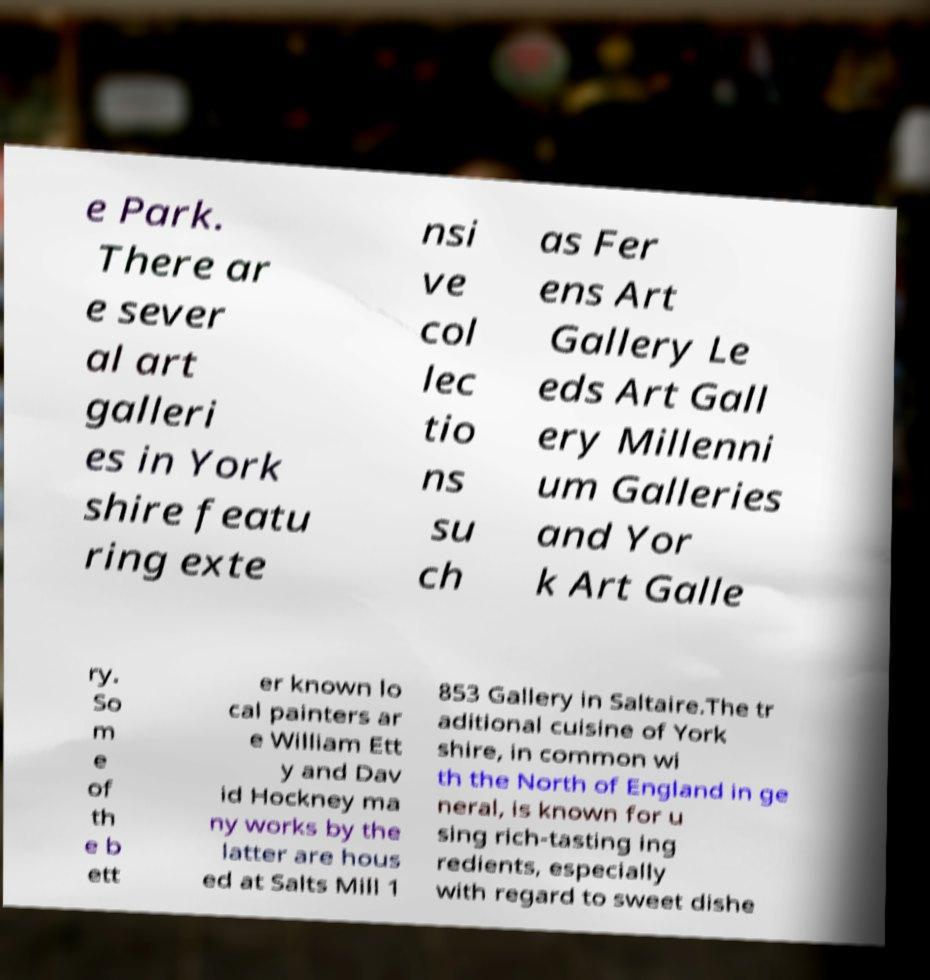There's text embedded in this image that I need extracted. Can you transcribe it verbatim? e Park. There ar e sever al art galleri es in York shire featu ring exte nsi ve col lec tio ns su ch as Fer ens Art Gallery Le eds Art Gall ery Millenni um Galleries and Yor k Art Galle ry. So m e of th e b ett er known lo cal painters ar e William Ett y and Dav id Hockney ma ny works by the latter are hous ed at Salts Mill 1 853 Gallery in Saltaire.The tr aditional cuisine of York shire, in common wi th the North of England in ge neral, is known for u sing rich-tasting ing redients, especially with regard to sweet dishe 